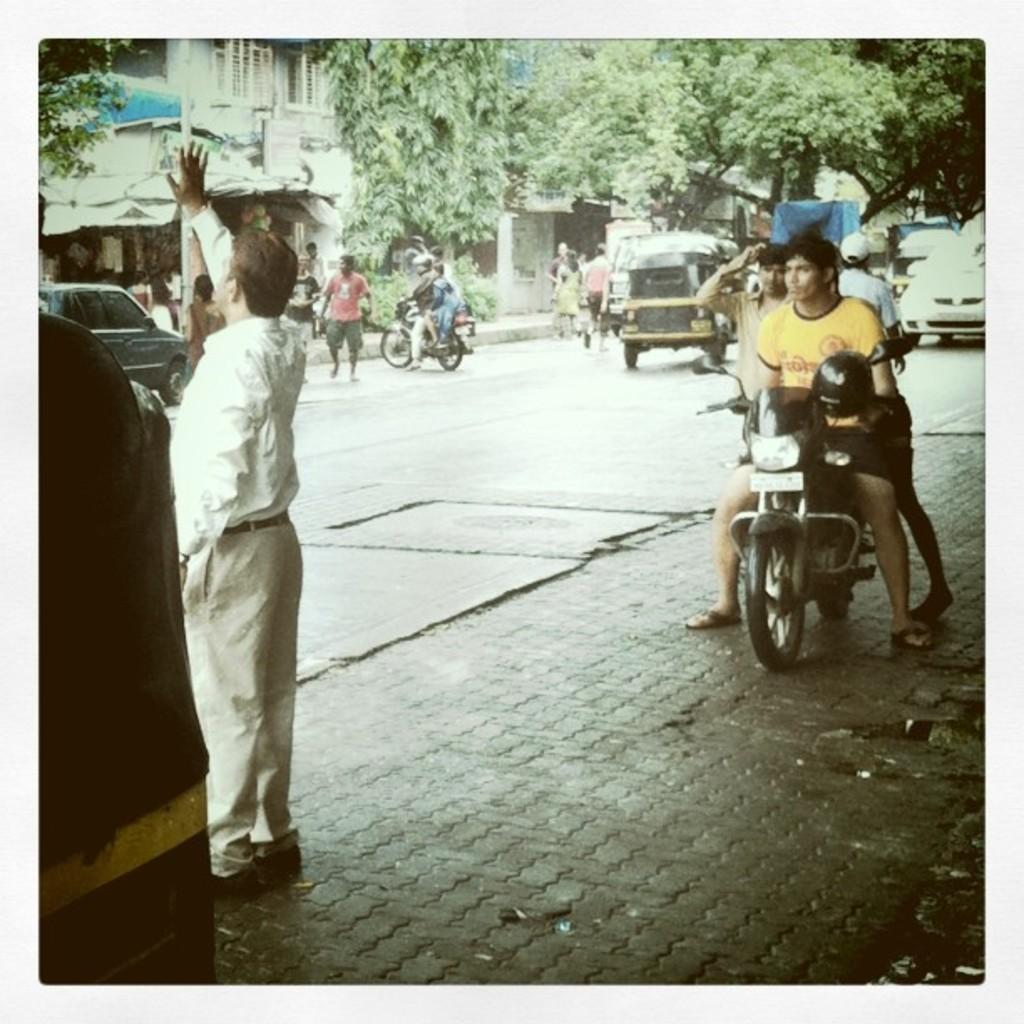How would you summarize this image in a sentence or two? In the image we can see there is a man who is standing on the road and beside him there are two people who are sitting on the bike and at the back there is an auto standing on the road. On the other side there are lot of trees and buildings. 